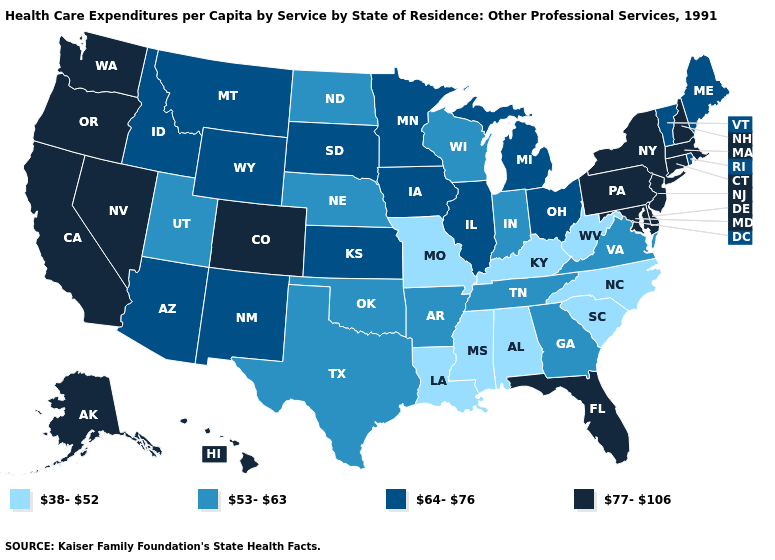Is the legend a continuous bar?
Answer briefly. No. What is the value of Nebraska?
Quick response, please. 53-63. Does Washington have the highest value in the USA?
Quick response, please. Yes. Does the map have missing data?
Answer briefly. No. Name the states that have a value in the range 77-106?
Short answer required. Alaska, California, Colorado, Connecticut, Delaware, Florida, Hawaii, Maryland, Massachusetts, Nevada, New Hampshire, New Jersey, New York, Oregon, Pennsylvania, Washington. Which states hav the highest value in the West?
Be succinct. Alaska, California, Colorado, Hawaii, Nevada, Oregon, Washington. Does the first symbol in the legend represent the smallest category?
Short answer required. Yes. What is the value of Colorado?
Quick response, please. 77-106. What is the value of Maryland?
Quick response, please. 77-106. What is the highest value in the MidWest ?
Give a very brief answer. 64-76. Does Montana have the highest value in the West?
Short answer required. No. What is the value of Texas?
Keep it brief. 53-63. What is the value of Connecticut?
Concise answer only. 77-106. Name the states that have a value in the range 64-76?
Give a very brief answer. Arizona, Idaho, Illinois, Iowa, Kansas, Maine, Michigan, Minnesota, Montana, New Mexico, Ohio, Rhode Island, South Dakota, Vermont, Wyoming. What is the value of Utah?
Be succinct. 53-63. 